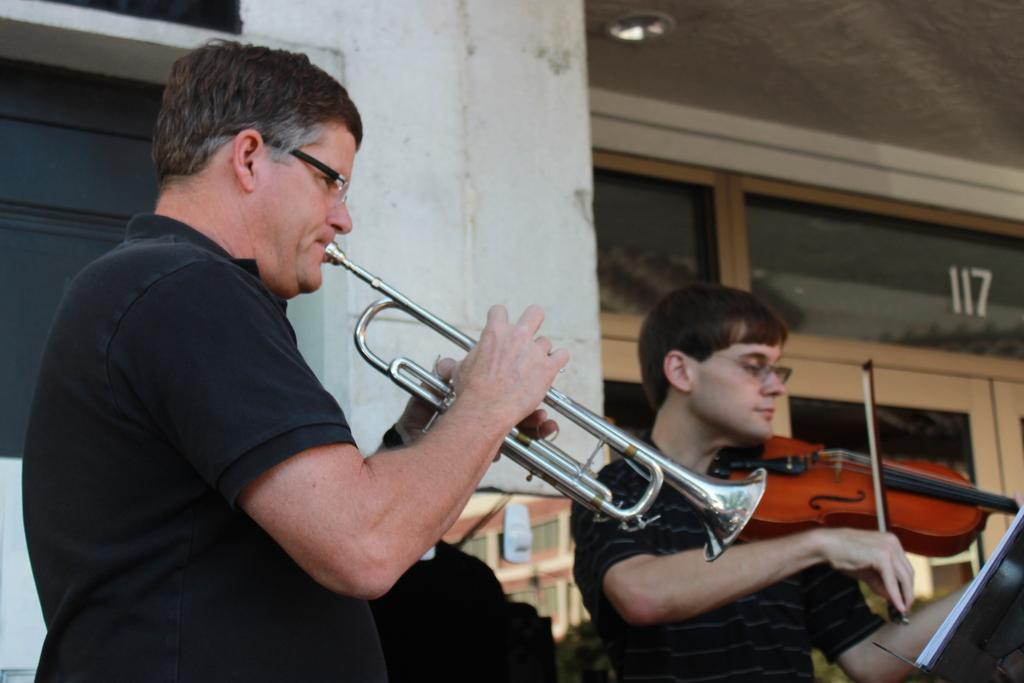What is the main subject of the image? There is a man playing a trumpet in the image. How is the trumpet being held by the man? The man is holding the trumpet in his hand. Are there any other people in the image? Yes, there is another man in the image. What is the second man doing in the image? The second man is playing a violin. What type of brake can be seen on the violin in the image? There is no brake present on the violin in the image, as violins do not have brakes. 